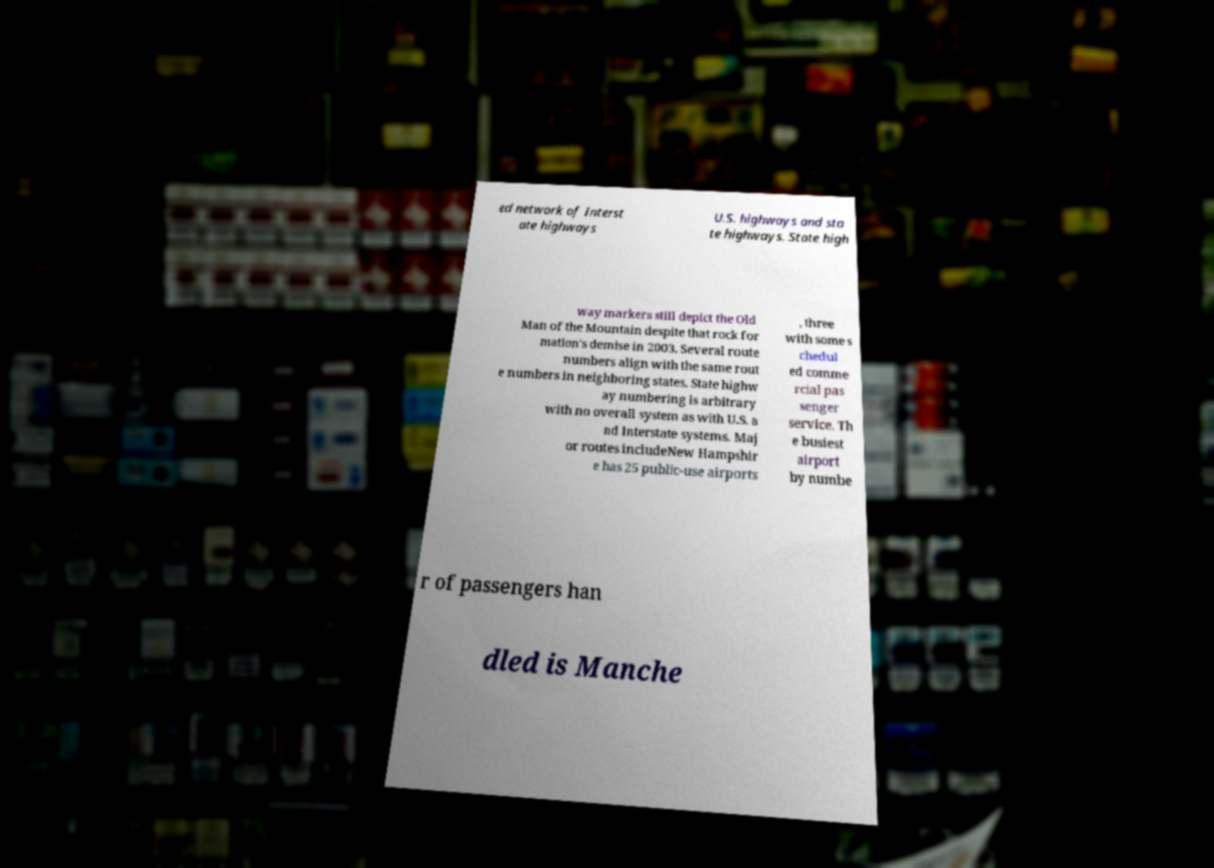What messages or text are displayed in this image? I need them in a readable, typed format. ed network of Interst ate highways U.S. highways and sta te highways. State high way markers still depict the Old Man of the Mountain despite that rock for mation's demise in 2003. Several route numbers align with the same rout e numbers in neighboring states. State highw ay numbering is arbitrary with no overall system as with U.S. a nd Interstate systems. Maj or routes includeNew Hampshir e has 25 public-use airports , three with some s chedul ed comme rcial pas senger service. Th e busiest airport by numbe r of passengers han dled is Manche 